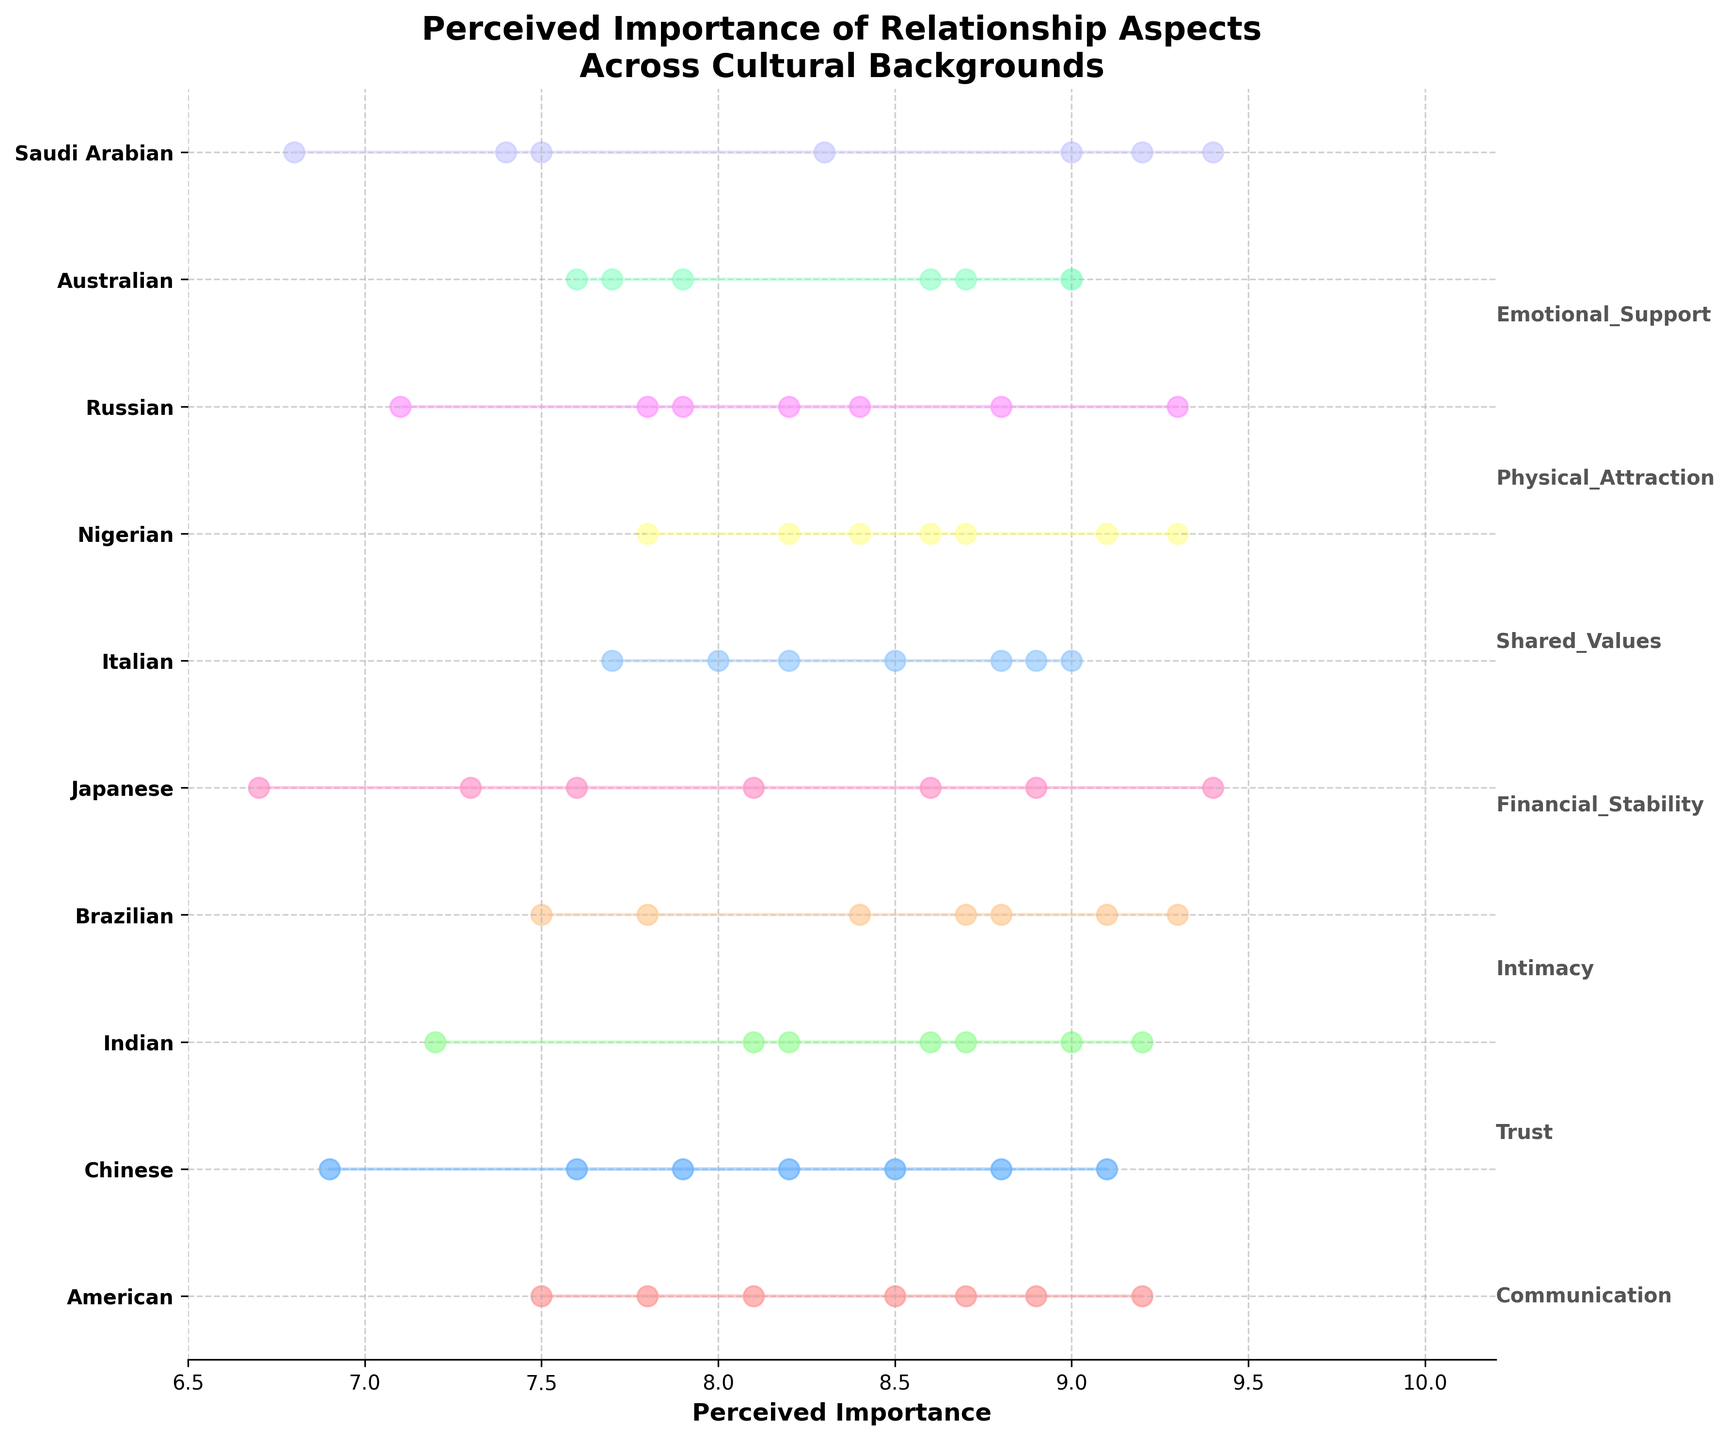What's the title of the figure? The title of the figure is displayed at the top and is in bold letters.
Answer: Perceived Importance of Relationship Aspects Across Cultural Backgrounds Which cultural background values 'Trust' the highest? Locate the data points for 'Trust' across all cultural backgrounds and identify which one is at the highest position.
Answer: Japanese What relationship aspect does the 'Saudi Arabian' culture find the least important? Look for the cultural background 'Saudi Arabian' and identify the lowest data point among its aspects.
Answer: Physical Attraction Which cultural backgrounds value 'Intimacy' higher than 9.0? Scan the 'Intimacy' values for all cultural backgrounds and identify which ones are greater than 9.0.
Answer: Brazilian Which cultural backgrounds rate 'Financial Stability' higher than 'Communication'? For each cultural background, compare the 'Financial Stability' score to the 'Communication' score. List the ones where the former is higher.
Answer: Chinese, Japanese, Saudi Arabian Which relationship aspect shows the maximum variation across cultural backgrounds? Calculate the range (max - min) for each relationship aspect and identify the one with the highest range.
Answer: Physical Attraction Which two cultural backgrounds have the closest average perceived importance across all relationship aspects? Calculate the average perceived importance for each cultural background and find the two with the smallest difference.
Answer: American and Australian Between 'Italian' and 'Nigerian' cultural backgrounds, which one considers 'Shared Values' more important? Compare the 'Shared Values' scores for 'Italian' and 'Nigerian' cultural backgrounds.
Answer: Nigerian Is 'Emotional Support' rated consistently high across cultural backgrounds? Review the 'Emotional Support' values for all cultural backgrounds and check for consistency in high ratings (e.g., around 8 or higher).
Answer: Yes What is the average perceived importance of 'Physical Attraction' across all cultural backgrounds? Sum up all the 'Physical Attraction' scores and divide by the number of cultural backgrounds.
Answer: 7.82 